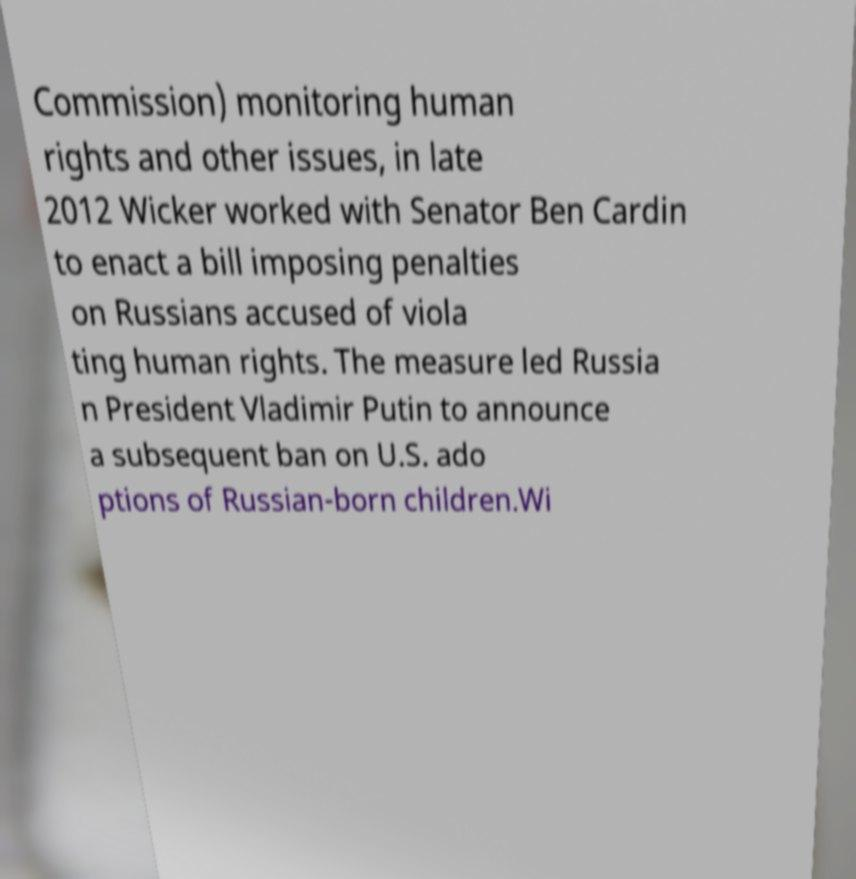Can you accurately transcribe the text from the provided image for me? Commission) monitoring human rights and other issues, in late 2012 Wicker worked with Senator Ben Cardin to enact a bill imposing penalties on Russians accused of viola ting human rights. The measure led Russia n President Vladimir Putin to announce a subsequent ban on U.S. ado ptions of Russian-born children.Wi 